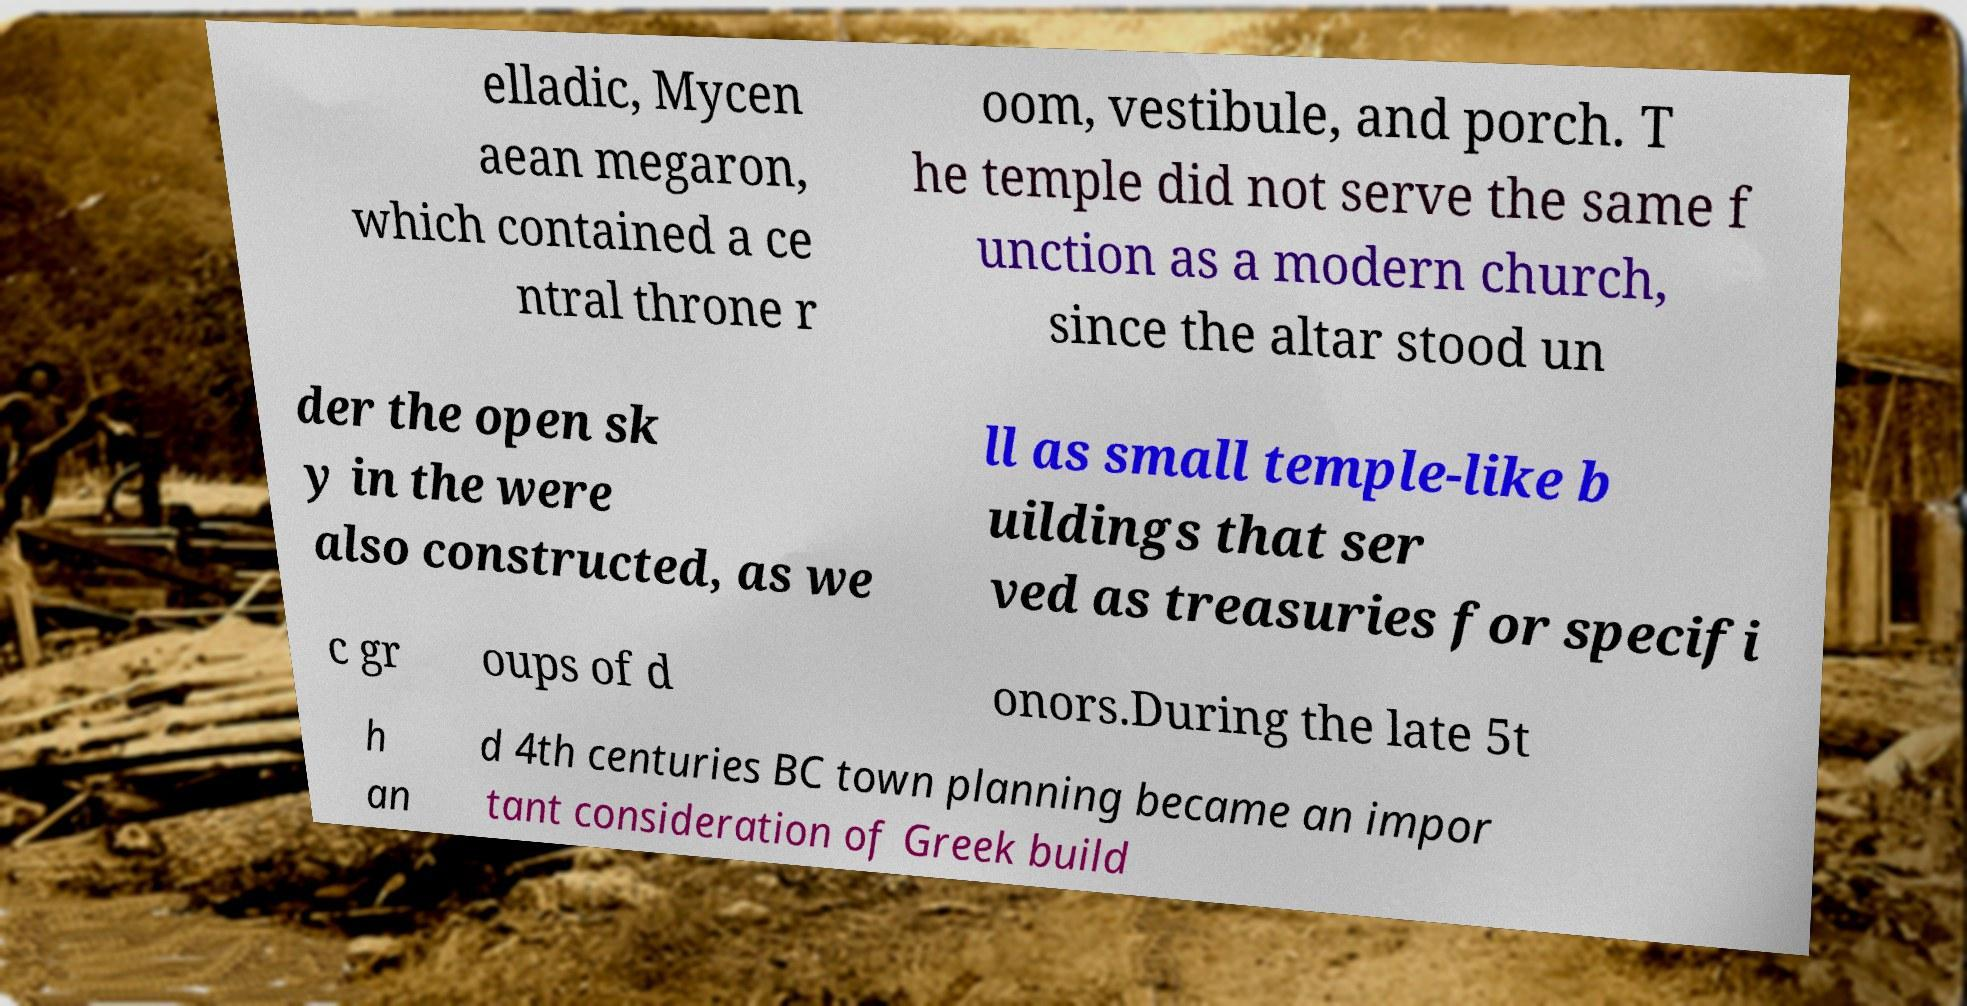Can you accurately transcribe the text from the provided image for me? elladic, Mycen aean megaron, which contained a ce ntral throne r oom, vestibule, and porch. T he temple did not serve the same f unction as a modern church, since the altar stood un der the open sk y in the were also constructed, as we ll as small temple-like b uildings that ser ved as treasuries for specifi c gr oups of d onors.During the late 5t h an d 4th centuries BC town planning became an impor tant consideration of Greek build 